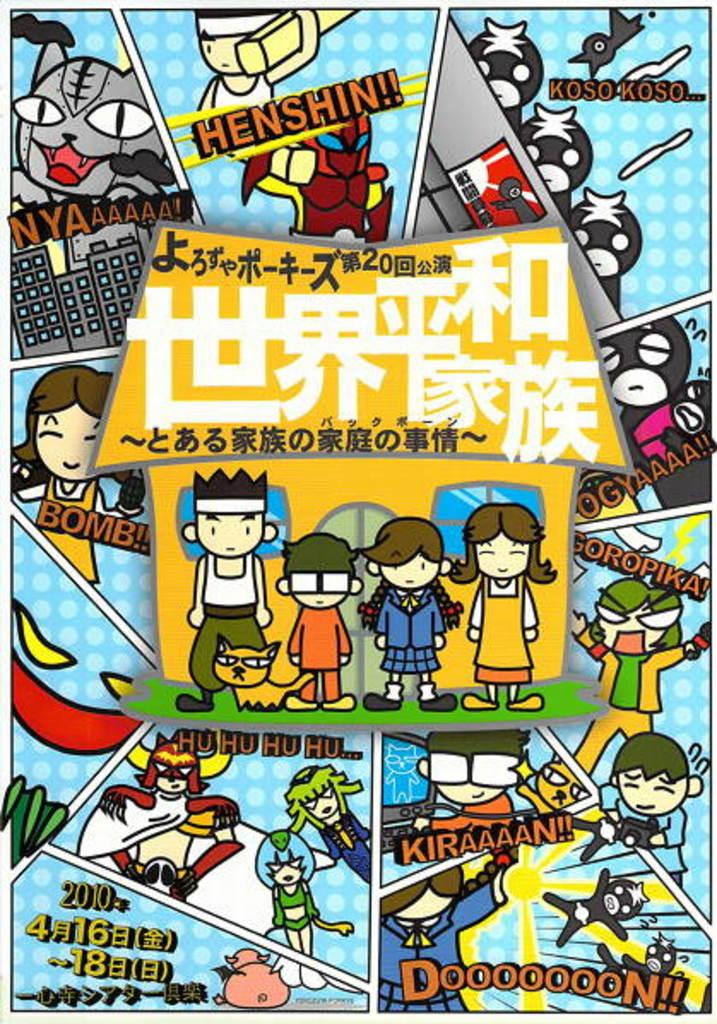<image>
Summarize the visual content of the image. A cartoon says Henshin!! In one of the top panels. 